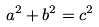Convert formula to latex. <formula><loc_0><loc_0><loc_500><loc_500>a ^ { 2 } + b ^ { 2 } = c ^ { 2 }</formula> 